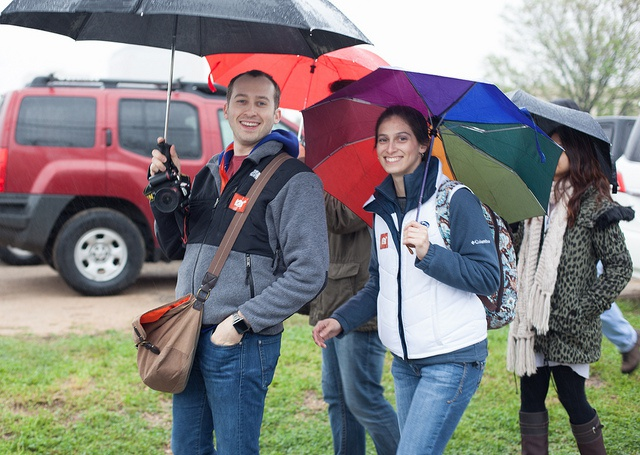Describe the objects in this image and their specific colors. I can see people in white, black, gray, and navy tones, truck in white, gray, darkgray, black, and lightpink tones, people in white, lavender, blue, gray, and navy tones, people in white, black, gray, lightgray, and darkgray tones, and umbrella in white, gray, teal, brown, and purple tones in this image. 